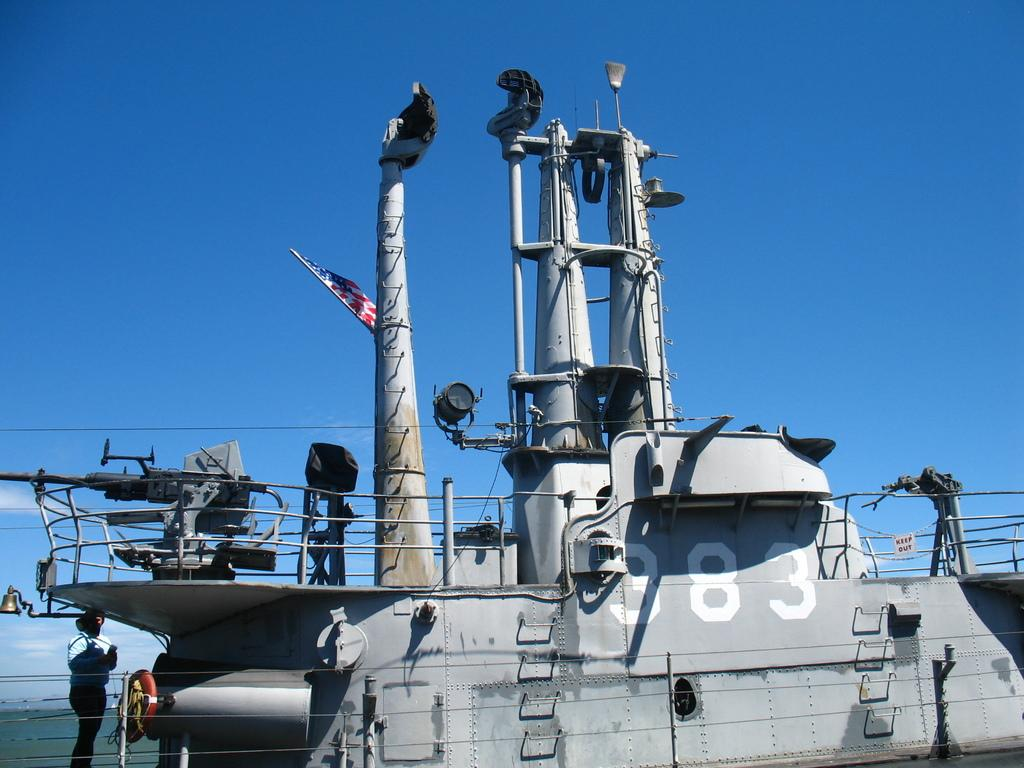What is the main subject of the picture? The main subject of the picture is a ship. What can be seen on the ship? There is equipment on the ship. Is there anyone visible on the ship? Yes, there is a person standing on the left side of the ship. What type of tin can be seen on the ship in the image? There is no tin present on the ship in the image. How does the person on the ship show respect to the airplane? There is no airplane present in the image, so it is not possible to determine how the person might show respect to an airplane. 